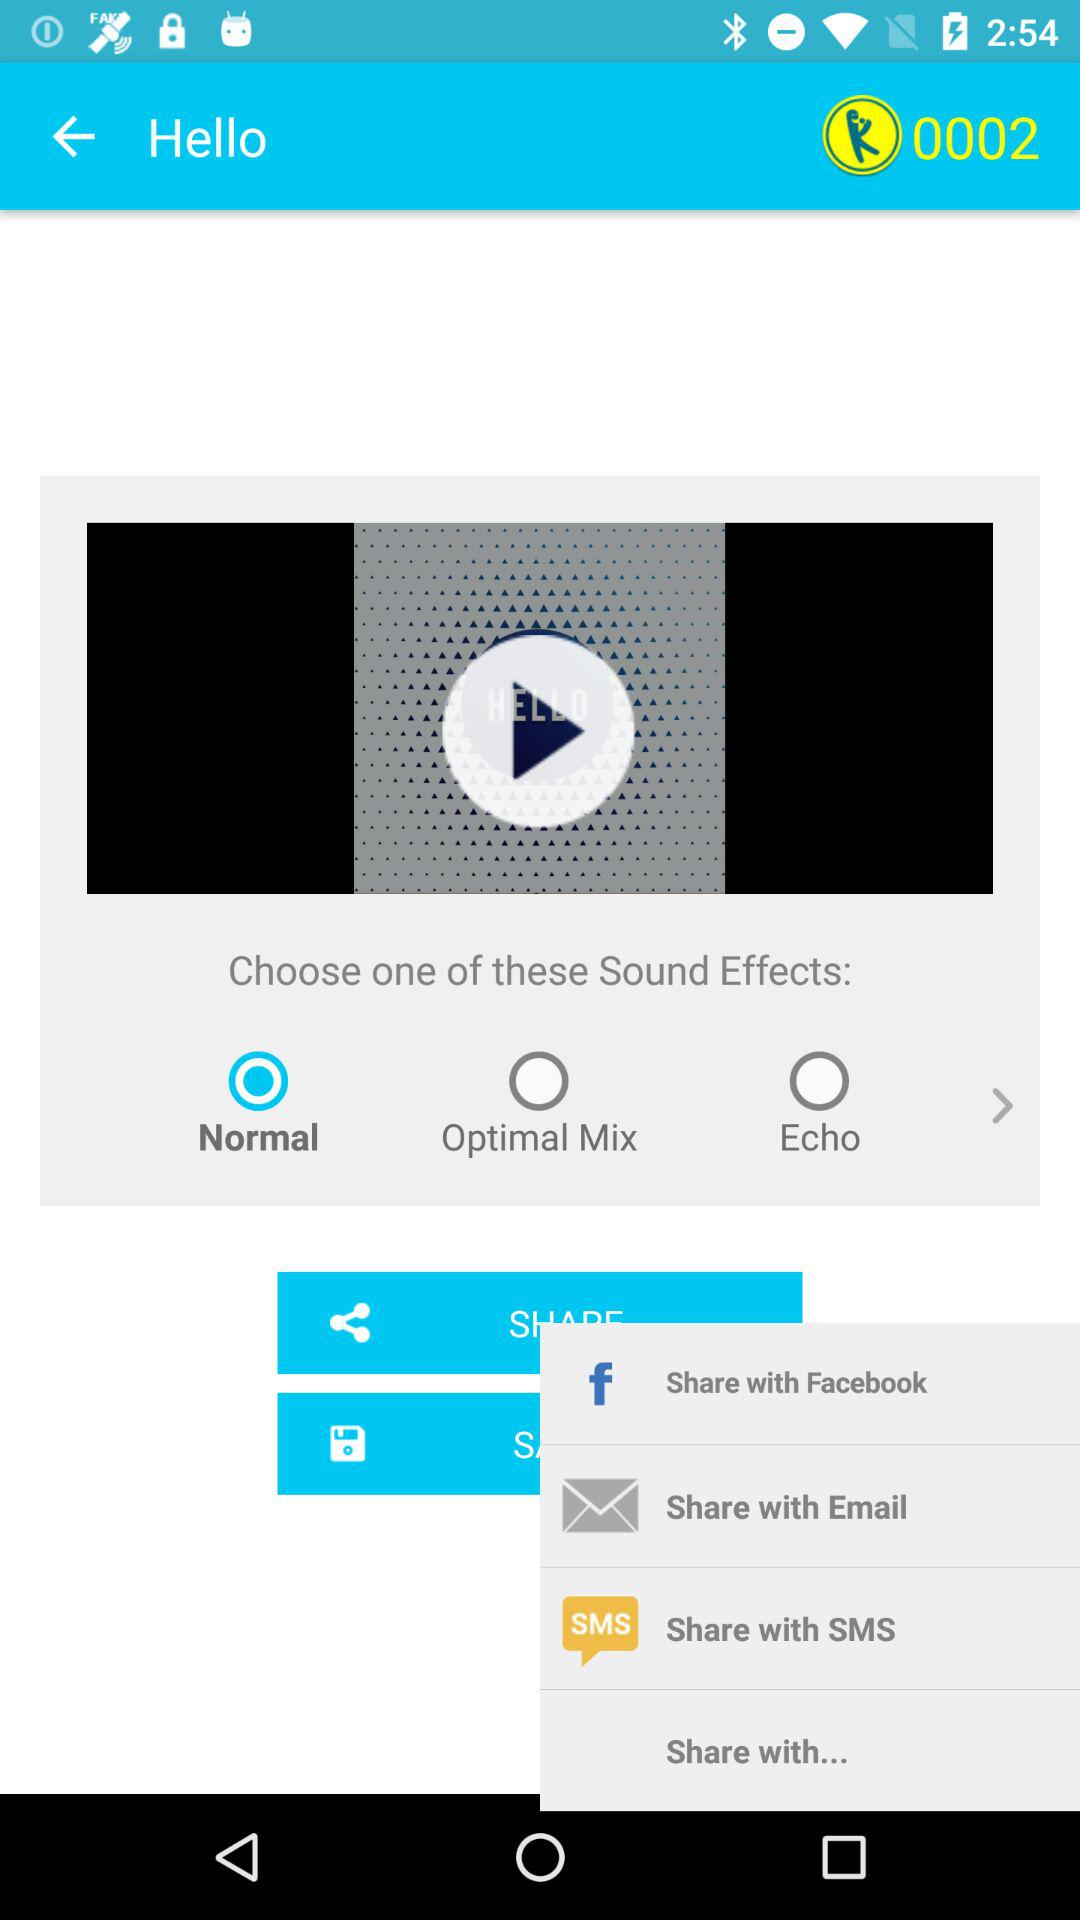What is the duration of the sound effect?
When the provided information is insufficient, respond with <no answer>. <no answer> 